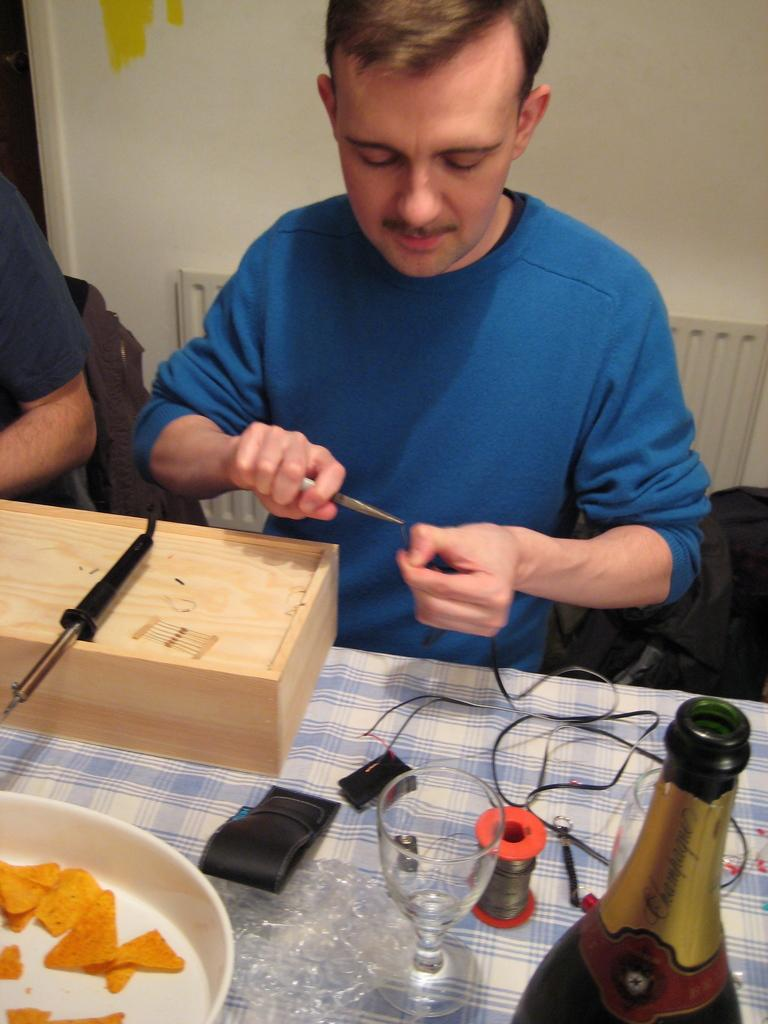How many people are in the image? There are people in the image, but the exact number cannot be determined from the provided facts. What are the people doing in the image? The people are seated on chairs in the image. What objects are on the table in the image? There is a box, a glass, a bottle, and a plate on the table in the image. Are there any other items on the table? Yes, there are other things on the table in the image. What type of blade is being used to cut the sugar in the image? There is no blade or sugar present in the image. 